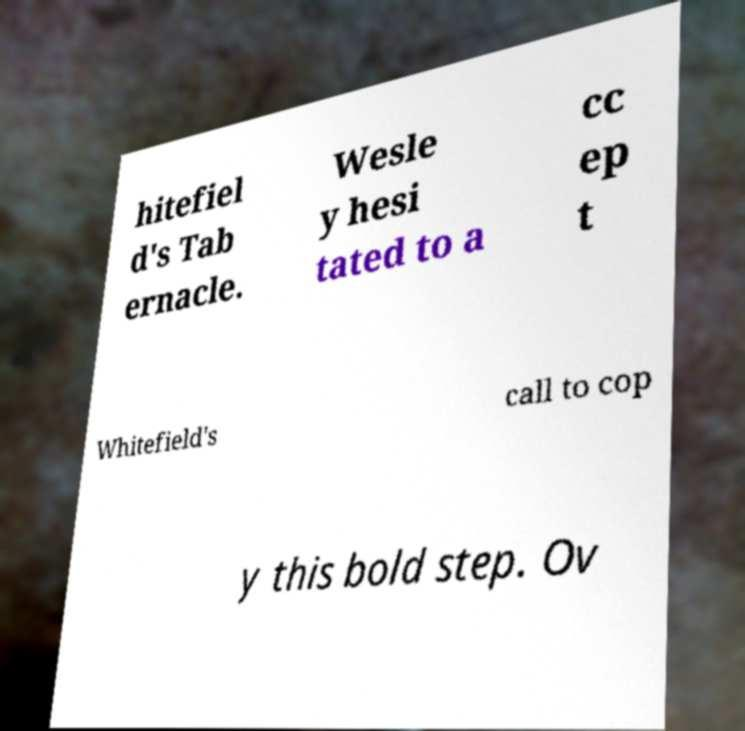For documentation purposes, I need the text within this image transcribed. Could you provide that? hitefiel d's Tab ernacle. Wesle y hesi tated to a cc ep t Whitefield's call to cop y this bold step. Ov 